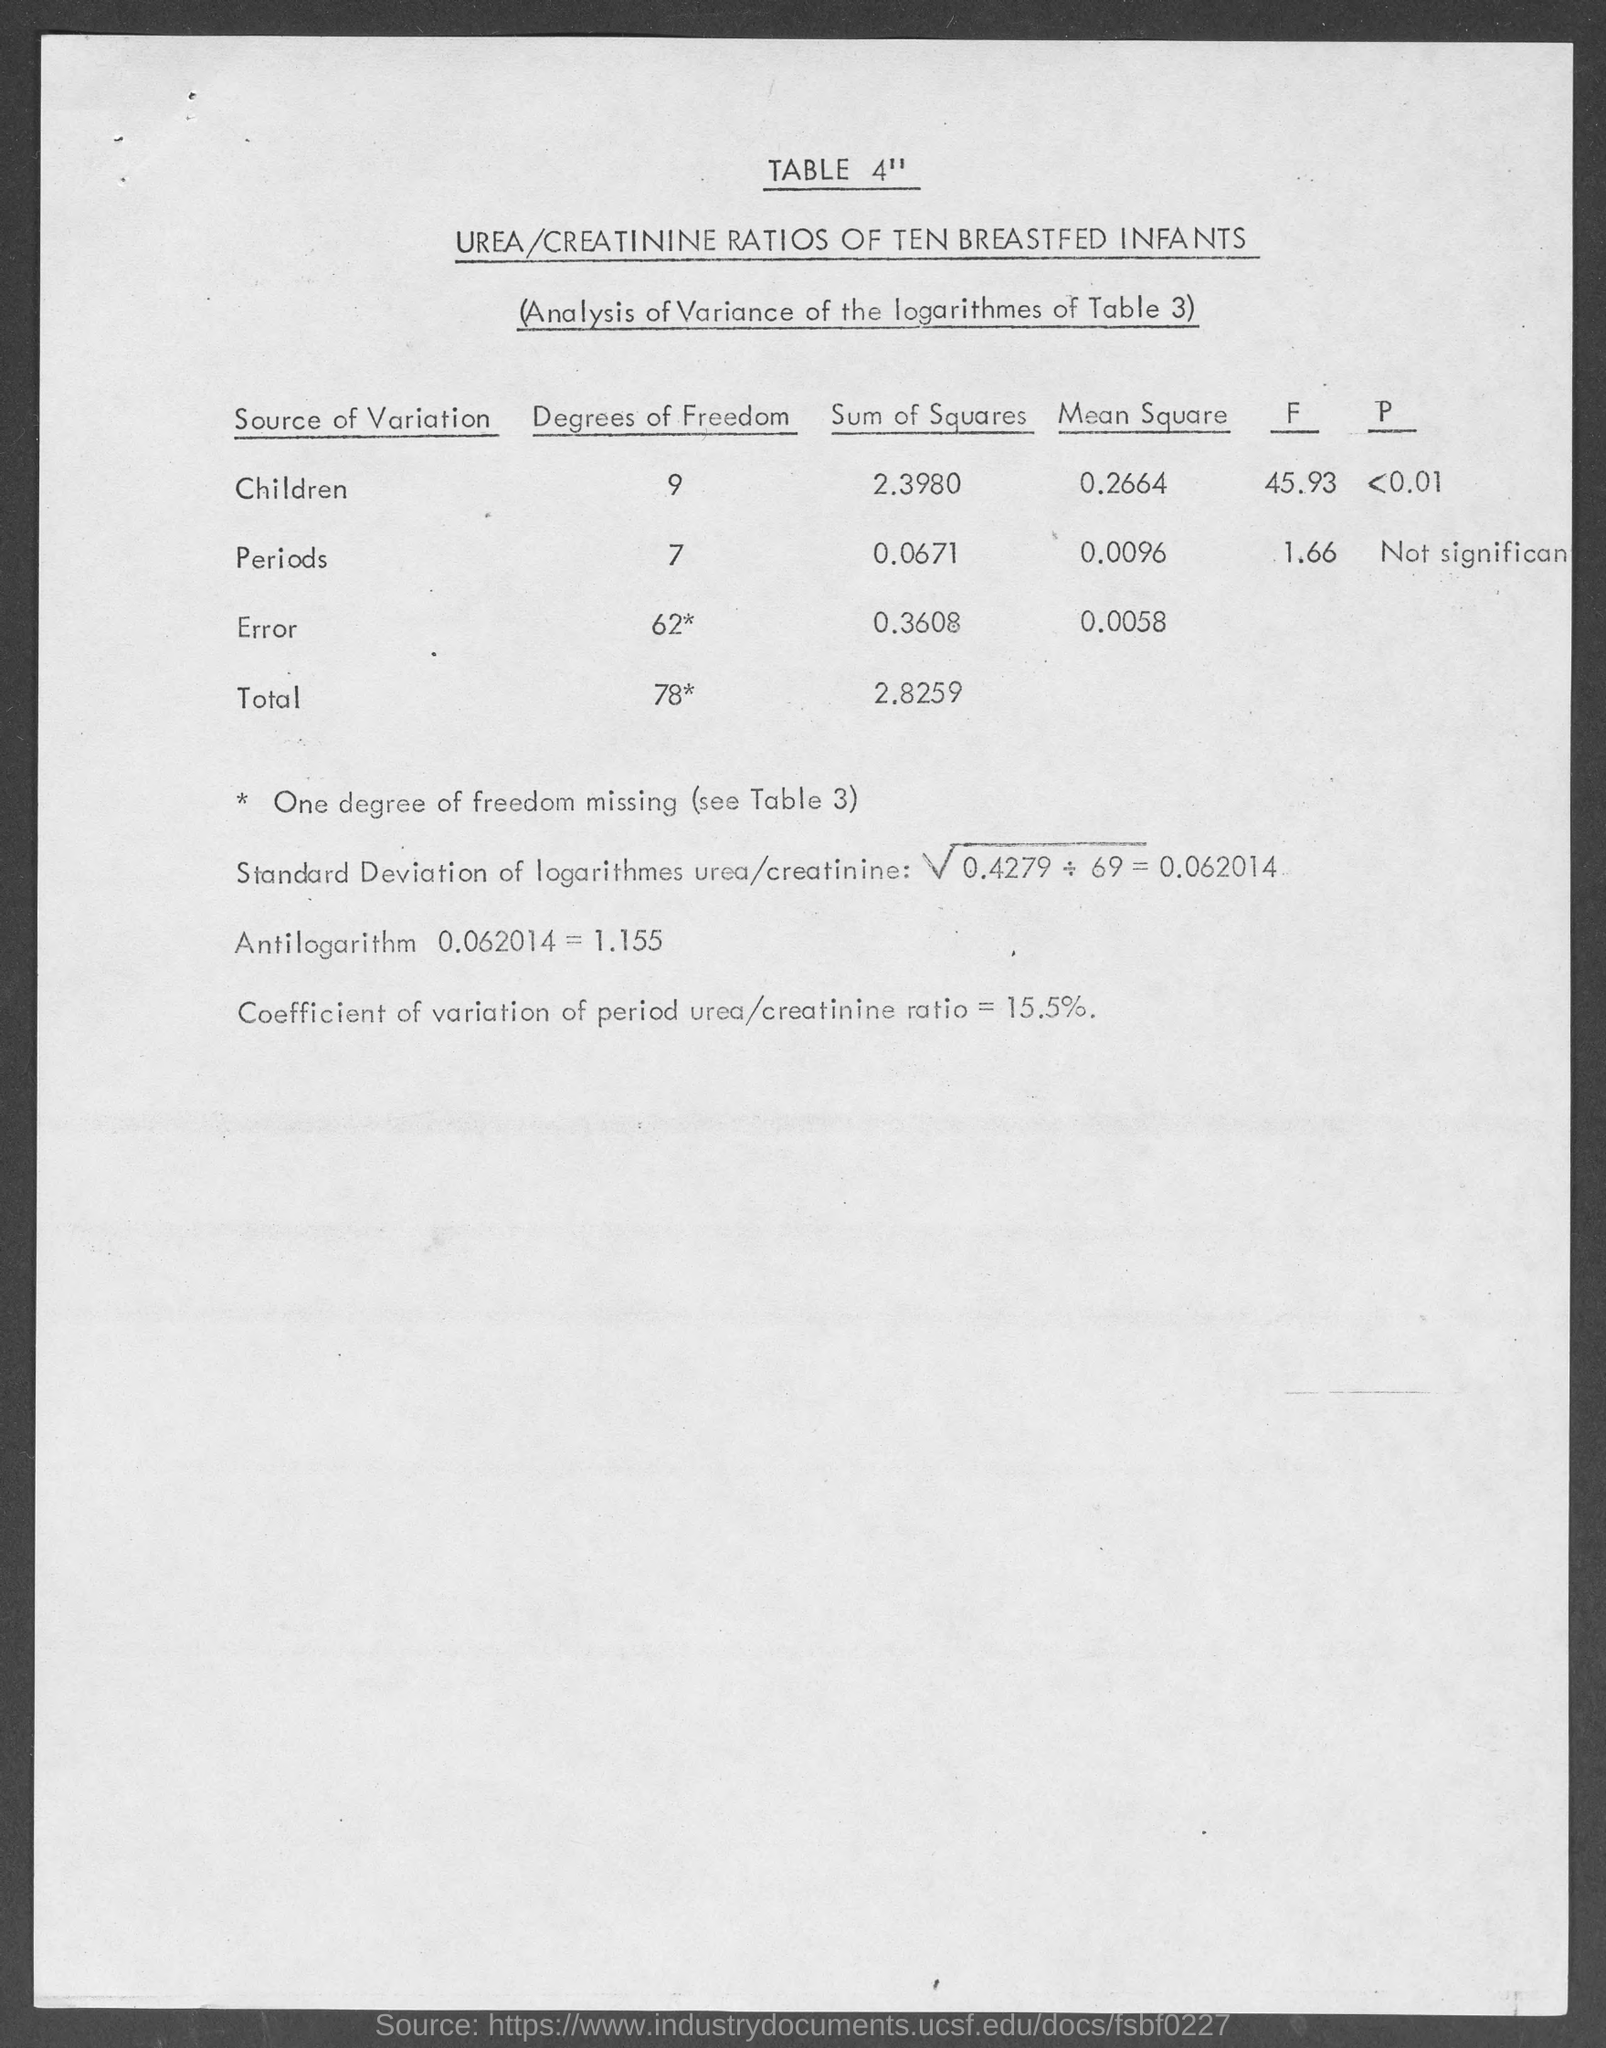List a handful of essential elements in this visual. This table displays the urea/creatinine ratios of ten breastfed infants. The antilogarithm value of 0.062014 is approximately 0.003252. The degrees of freedom for children is 9. The coefficient of variation of the period urea/creatinine ratio is 15.5%. 